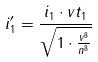<formula> <loc_0><loc_0><loc_500><loc_500>i _ { 1 } ^ { \prime } = \frac { i _ { 1 } \cdot v t _ { 1 } } { \sqrt { 1 \cdot \frac { v ^ { 8 } } { n ^ { 8 } } } }</formula> 